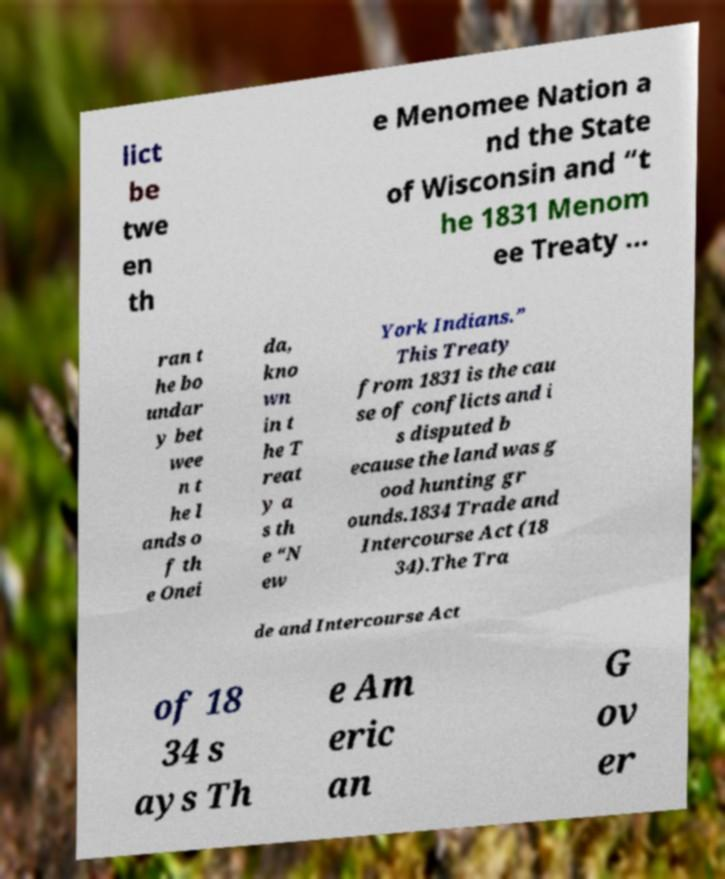Could you assist in decoding the text presented in this image and type it out clearly? lict be twe en th e Menomee Nation a nd the State of Wisconsin and “t he 1831 Menom ee Treaty … ran t he bo undar y bet wee n t he l ands o f th e Onei da, kno wn in t he T reat y a s th e “N ew York Indians.” This Treaty from 1831 is the cau se of conflicts and i s disputed b ecause the land was g ood hunting gr ounds.1834 Trade and Intercourse Act (18 34).The Tra de and Intercourse Act of 18 34 s ays Th e Am eric an G ov er 